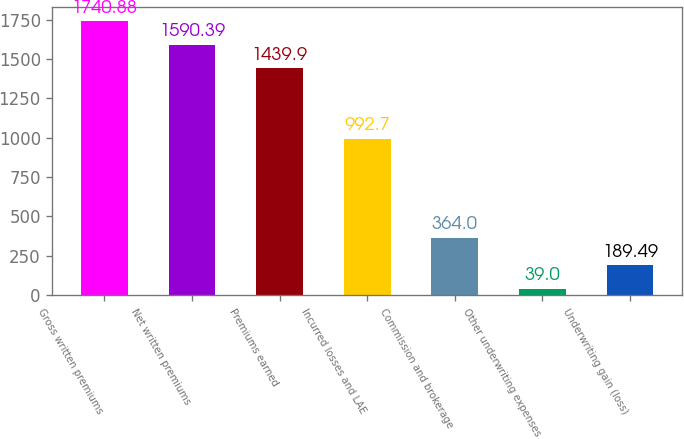<chart> <loc_0><loc_0><loc_500><loc_500><bar_chart><fcel>Gross written premiums<fcel>Net written premiums<fcel>Premiums earned<fcel>Incurred losses and LAE<fcel>Commission and brokerage<fcel>Other underwriting expenses<fcel>Underwriting gain (loss)<nl><fcel>1740.88<fcel>1590.39<fcel>1439.9<fcel>992.7<fcel>364<fcel>39<fcel>189.49<nl></chart> 